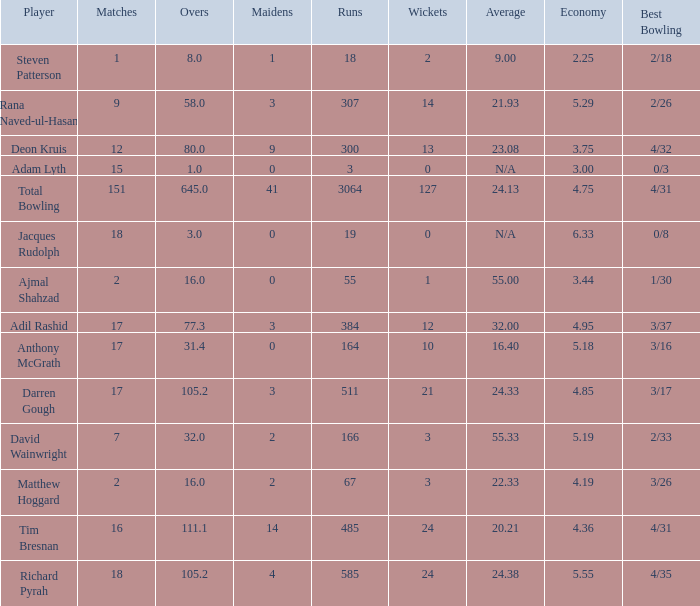What is the lowest Overs with a Run that is 18? 8.0. Can you parse all the data within this table? {'header': ['Player', 'Matches', 'Overs', 'Maidens', 'Runs', 'Wickets', 'Average', 'Economy', 'Best Bowling'], 'rows': [['Steven Patterson', '1', '8.0', '1', '18', '2', '9.00', '2.25', '2/18'], ['Rana Naved-ul-Hasan', '9', '58.0', '3', '307', '14', '21.93', '5.29', '2/26'], ['Deon Kruis', '12', '80.0', '9', '300', '13', '23.08', '3.75', '4/32'], ['Adam Lyth', '15', '1.0', '0', '3', '0', 'N/A', '3.00', '0/3'], ['Total Bowling', '151', '645.0', '41', '3064', '127', '24.13', '4.75', '4/31'], ['Jacques Rudolph', '18', '3.0', '0', '19', '0', 'N/A', '6.33', '0/8'], ['Ajmal Shahzad', '2', '16.0', '0', '55', '1', '55.00', '3.44', '1/30'], ['Adil Rashid', '17', '77.3', '3', '384', '12', '32.00', '4.95', '3/37'], ['Anthony McGrath', '17', '31.4', '0', '164', '10', '16.40', '5.18', '3/16'], ['Darren Gough', '17', '105.2', '3', '511', '21', '24.33', '4.85', '3/17'], ['David Wainwright', '7', '32.0', '2', '166', '3', '55.33', '5.19', '2/33'], ['Matthew Hoggard', '2', '16.0', '2', '67', '3', '22.33', '4.19', '3/26'], ['Tim Bresnan', '16', '111.1', '14', '485', '24', '20.21', '4.36', '4/31'], ['Richard Pyrah', '18', '105.2', '4', '585', '24', '24.38', '5.55', '4/35']]} 